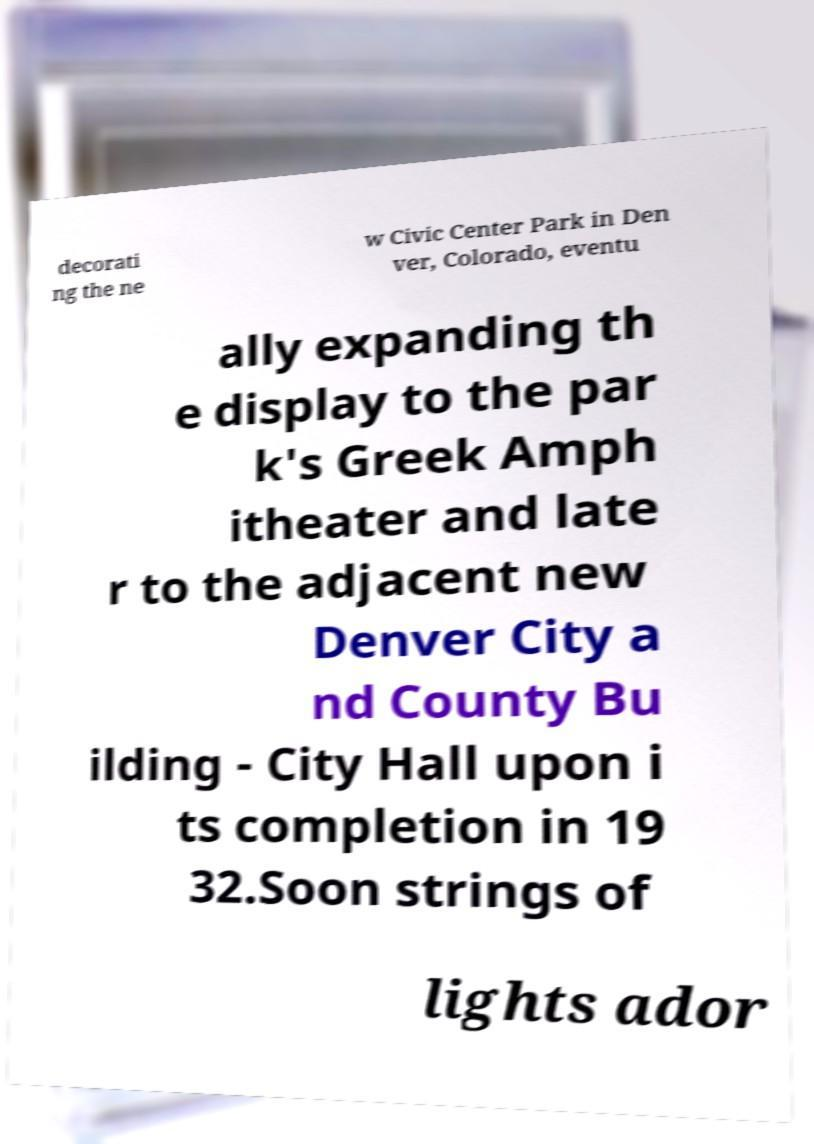Please identify and transcribe the text found in this image. decorati ng the ne w Civic Center Park in Den ver, Colorado, eventu ally expanding th e display to the par k's Greek Amph itheater and late r to the adjacent new Denver City a nd County Bu ilding - City Hall upon i ts completion in 19 32.Soon strings of lights ador 